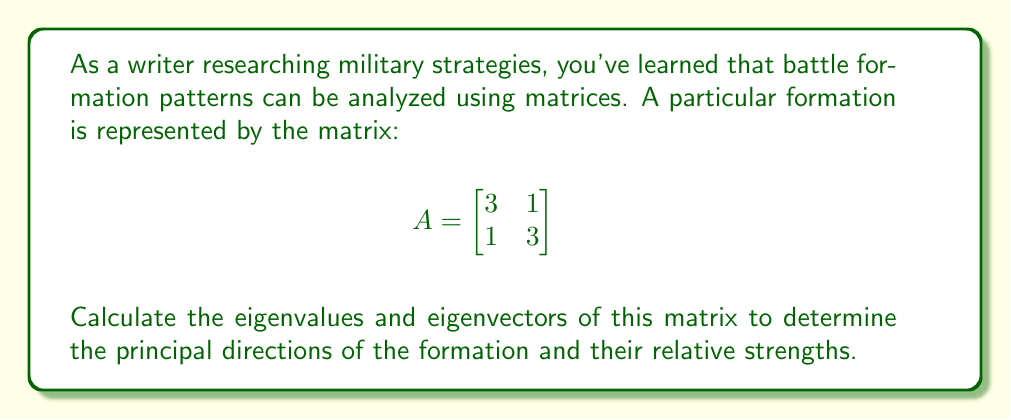Show me your answer to this math problem. 1. To find eigenvalues, we solve the characteristic equation:
   $det(A - \lambda I) = 0$

2. Expand the determinant:
   $$\begin{vmatrix}
   3-\lambda & 1 \\
   1 & 3-\lambda
   \end{vmatrix} = 0$$

3. Solve the equation:
   $(3-\lambda)^2 - 1 = 0$
   $\lambda^2 - 6\lambda + 8 = 0$

4. Factor and solve:
   $(\lambda - 4)(\lambda - 2) = 0$
   $\lambda_1 = 4, \lambda_2 = 2$

5. For $\lambda_1 = 4$, find eigenvector $v_1$:
   $$(A - 4I)v_1 = \begin{bmatrix}
   -1 & 1 \\
   1 & -1
   \end{bmatrix}\begin{bmatrix}
   x \\
   y
   \end{bmatrix} = \begin{bmatrix}
   0 \\
   0
   \end{bmatrix}$$

   This gives: $x = y$. Choose $v_1 = \begin{bmatrix} 1 \\ 1 \end{bmatrix}$

6. For $\lambda_2 = 2$, find eigenvector $v_2$:
   $$(A - 2I)v_2 = \begin{bmatrix}
   1 & 1 \\
   1 & 1
   \end{bmatrix}\begin{bmatrix}
   x \\
   y
   \end{bmatrix} = \begin{bmatrix}
   0 \\
   0
   \end{bmatrix}$$

   This gives: $x = -y$. Choose $v_2 = \begin{bmatrix} 1 \\ -1 \end{bmatrix}$
Answer: Eigenvalues: $\lambda_1 = 4, \lambda_2 = 2$
Eigenvectors: $v_1 = \begin{bmatrix} 1 \\ 1 \end{bmatrix}, v_2 = \begin{bmatrix} 1 \\ -1 \end{bmatrix}$ 